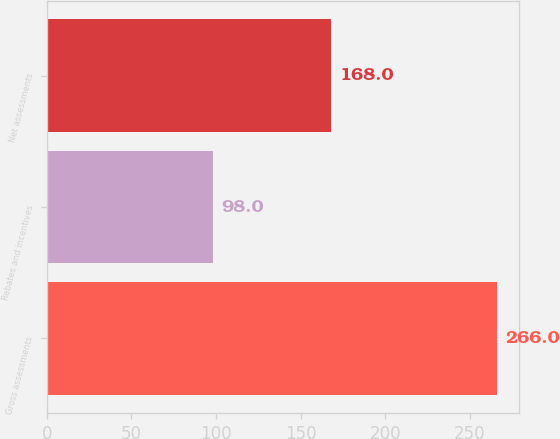Convert chart. <chart><loc_0><loc_0><loc_500><loc_500><bar_chart><fcel>Gross assessments<fcel>Rebates and incentives<fcel>Net assessments<nl><fcel>266<fcel>98<fcel>168<nl></chart> 